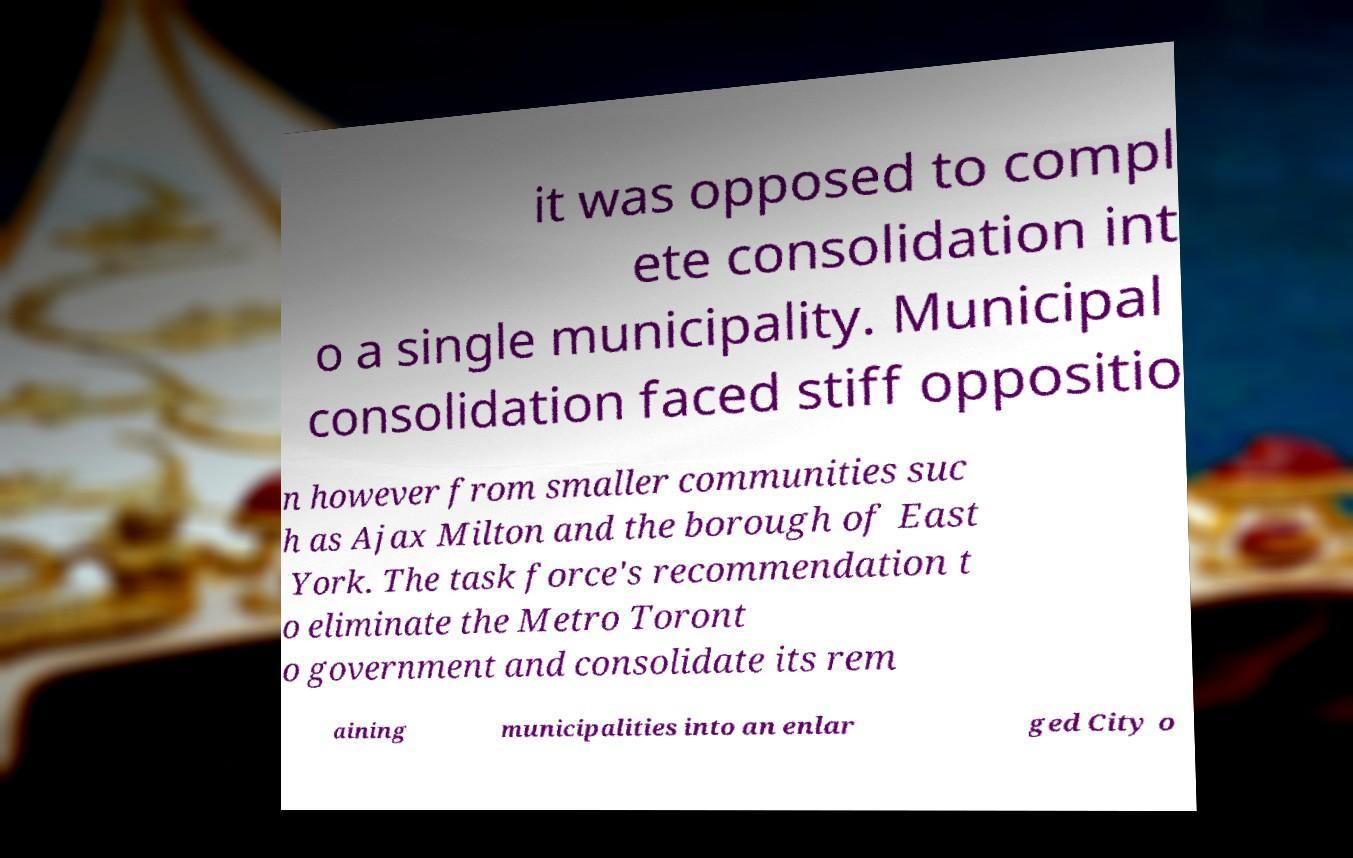Can you accurately transcribe the text from the provided image for me? it was opposed to compl ete consolidation int o a single municipality. Municipal consolidation faced stiff oppositio n however from smaller communities suc h as Ajax Milton and the borough of East York. The task force's recommendation t o eliminate the Metro Toront o government and consolidate its rem aining municipalities into an enlar ged City o 